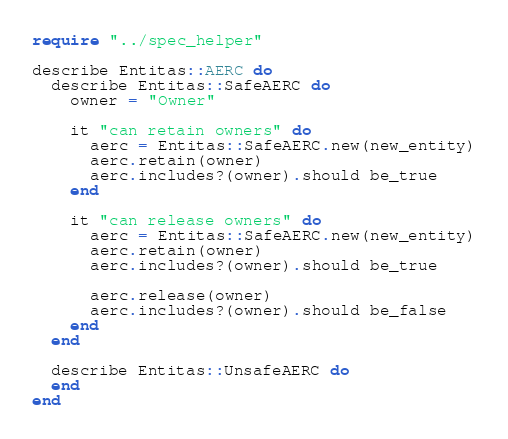<code> <loc_0><loc_0><loc_500><loc_500><_Crystal_>require "../spec_helper"

describe Entitas::AERC do
  describe Entitas::SafeAERC do
    owner = "Owner"

    it "can retain owners" do
      aerc = Entitas::SafeAERC.new(new_entity)
      aerc.retain(owner)
      aerc.includes?(owner).should be_true
    end

    it "can release owners" do
      aerc = Entitas::SafeAERC.new(new_entity)
      aerc.retain(owner)
      aerc.includes?(owner).should be_true

      aerc.release(owner)
      aerc.includes?(owner).should be_false
    end
  end

  describe Entitas::UnsafeAERC do
  end
end
</code> 